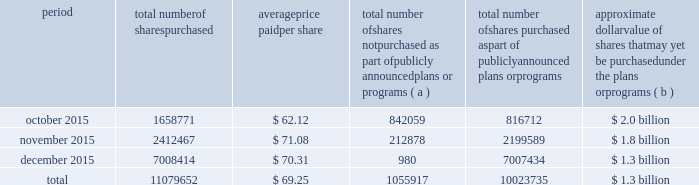Table of contents the table discloses purchases of shares of our common stock made by us or on our behalf during the fourth quarter of 2015 .
Period total number of shares purchased average price paid per share total number of shares not purchased as part of publicly announced plans or programs ( a ) total number of shares purchased as part of publicly announced plans or programs approximate dollar value of shares that may yet be purchased under the plans or programs ( b ) .
( a ) the shares reported in this column represent purchases settled in the fourth quarter of 2015 relating to ( i ) our purchases of shares in open-market transactions to meet our obligations under stock-based compensation plans , and ( ii ) our purchases of shares from our employees and non-employee directors in connection with the exercise of stock options , the vesting of restricted stock , and other stock compensation transactions in accordance with the terms of our stock-based compensation plans .
( b ) on july 13 , 2015 , we announced that our board of directors approved our purchase of $ 2.5 billion of our outstanding common stock ( with no expiration date ) , which was in addition to the remaining amount available under our $ 3 billion program previously authorized .
During the third quarter of 2015 , we completed our purchases under the $ 3 billion program .
As of december 31 , 2015 , we had $ 1.3 billion remaining available for purchase under the $ 2.5 billion program. .
For the fourth quarter ended december 312015 what was the percent of the total number of shares not purchased as part of publicly announced plans or programs in october? 
Computations: (842059 / 1055917)
Answer: 0.79747. Table of contents the table discloses purchases of shares of our common stock made by us or on our behalf during the fourth quarter of 2015 .
Period total number of shares purchased average price paid per share total number of shares not purchased as part of publicly announced plans or programs ( a ) total number of shares purchased as part of publicly announced plans or programs approximate dollar value of shares that may yet be purchased under the plans or programs ( b ) .
( a ) the shares reported in this column represent purchases settled in the fourth quarter of 2015 relating to ( i ) our purchases of shares in open-market transactions to meet our obligations under stock-based compensation plans , and ( ii ) our purchases of shares from our employees and non-employee directors in connection with the exercise of stock options , the vesting of restricted stock , and other stock compensation transactions in accordance with the terms of our stock-based compensation plans .
( b ) on july 13 , 2015 , we announced that our board of directors approved our purchase of $ 2.5 billion of our outstanding common stock ( with no expiration date ) , which was in addition to the remaining amount available under our $ 3 billion program previously authorized .
During the third quarter of 2015 , we completed our purchases under the $ 3 billion program .
As of december 31 , 2015 , we had $ 1.3 billion remaining available for purchase under the $ 2.5 billion program. .
What was the percentage increase of shares purchased in november to december? 
Computations: (7008414 - 2412467)
Answer: 4595947.0. 